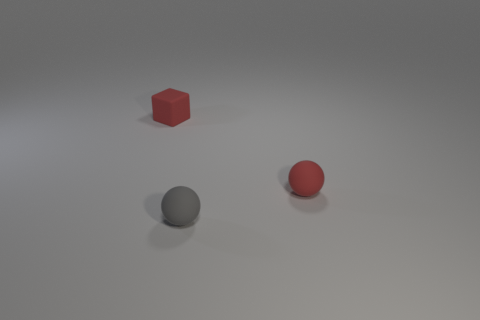What number of tiny objects are either gray spheres or rubber balls?
Ensure brevity in your answer.  2. There is a red thing that is the same shape as the gray matte object; what size is it?
Ensure brevity in your answer.  Small. How many objects are in front of the tiny matte block and left of the tiny gray matte thing?
Offer a terse response. 0. Does the gray matte object have the same shape as the rubber thing that is left of the tiny gray ball?
Make the answer very short. No. Is the number of tiny gray balls on the left side of the tiny red matte block greater than the number of red rubber balls?
Make the answer very short. No. Is the number of small matte cubes that are to the left of the red matte block less than the number of tiny gray rubber things?
Provide a succinct answer. Yes. How many matte spheres are the same color as the block?
Provide a succinct answer. 1. There is a object that is both behind the gray object and left of the small red matte ball; what is it made of?
Make the answer very short. Rubber. There is a thing on the left side of the gray object; is its color the same as the rubber object right of the tiny gray thing?
Your answer should be very brief. Yes. How many red things are either matte objects or matte spheres?
Offer a terse response. 2. 